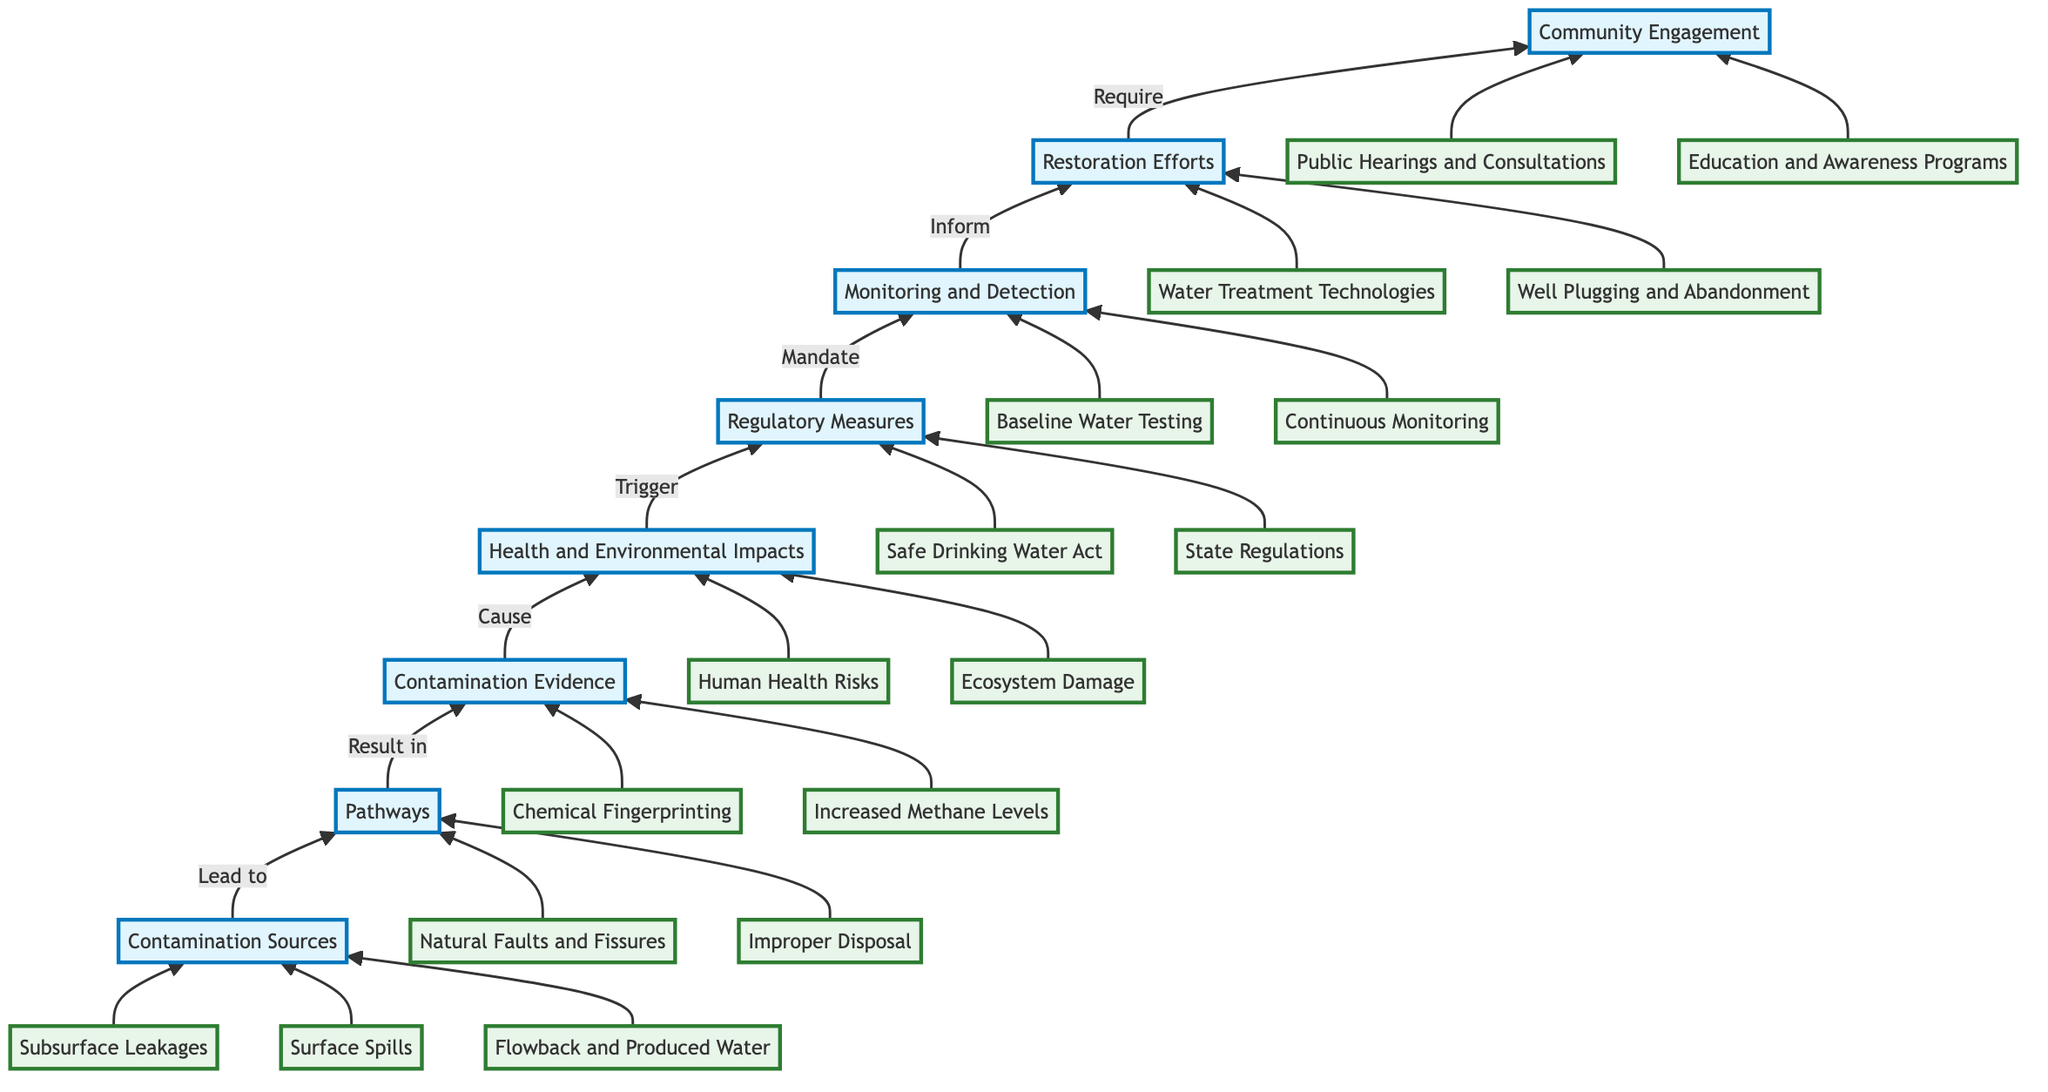What are the three sources of contamination? The diagram lists three specific sources of contamination under "Contamination Sources": Subsurface Leakages, Surface Spills, and Flowback and Produced Water.
Answer: Subsurface Leakages, Surface Spills, Flowback and Produced Water How many pathways lead to contamination evidence? The diagram shows two pathways listed under "Pathways": Natural Faults and Fissures and Improper Disposal. Therefore, there are a total of two pathways.
Answer: Two What evidence is used to identify contamination? The diagram indicates two pieces of evidence under "Contamination Evidence": Chemical Fingerprinting and Increased Methane Levels, which are used to identify contamination.
Answer: Chemical Fingerprinting, Increased Methane Levels What health issues are caused by water contamination? Under "Health and Environmental Impacts," two health issues are mentioned: Human Health Risks and Ecosystem Damage. These two points specify the health issues caused by water contamination.
Answer: Human Health Risks, Ecosystem Damage What regulatory measures are mandated after contamination evidence? The diagram specifies that after contamination evidence is observed, "Regulatory Measures" are triggered, which consist of the Safe Drinking Water Act and State Regulations, thus creating a mandatory response to the situation.
Answer: Regulatory Measures How do regulatory measures influence monitoring? According to the diagram, regulatory measures mandate monitoring and detection efforts. The flow indicates that after regulatory measures are put in place, they inform the monitoring activities that follow.
Answer: Inform Which restoration effort focuses on preventing leaks? "Well Plugging and Abandonment" is specifically mentioned under "Restoration Efforts" as the effort that focuses on preventing leaks, indicating its role in contamination prevention.
Answer: Well Plugging and Abandonment How many elements are focused on community engagement? The diagram mentions two elements under "Community Engagement": Public Hearings and Consultations and Education and Awareness Programs, signifying that there are two main focuses regarding community engagement.
Answer: Two 